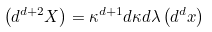<formula> <loc_0><loc_0><loc_500><loc_500>\left ( d ^ { d + 2 } X \right ) = \kappa ^ { d + 1 } d \kappa d \lambda \left ( d ^ { d } x \right )</formula> 